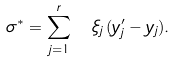<formula> <loc_0><loc_0><loc_500><loc_500>\sigma ^ { * } = \sum _ { j = 1 } ^ { r } \ \xi _ { j } \, ( y ^ { \prime } _ { j } - y _ { j } ) .</formula> 